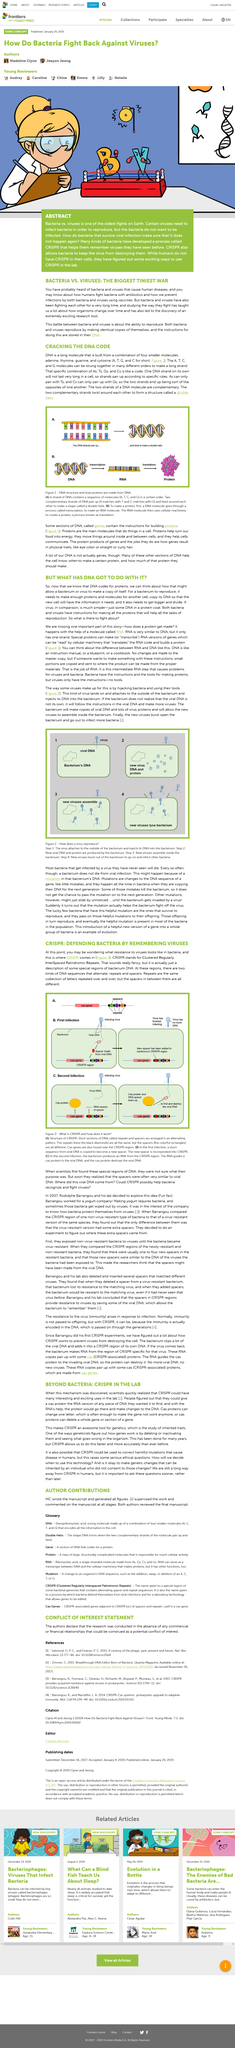List a handful of essential elements in this visual. The study of how viruses and bacteria fight has been conducted to gain insight into the evolution of organisms over time. Bacteria and viruses store instructions for reproducing in their DNA. DNA is formed by two complementary strands that twist around each other to create a double helix structure. It is a fact that DNA pairs up in a specific way, with A's pairing only with T's and G's pairing only with C's. Bacteria do not wish to be infected, as it would compromise their health and ability to thrive. 